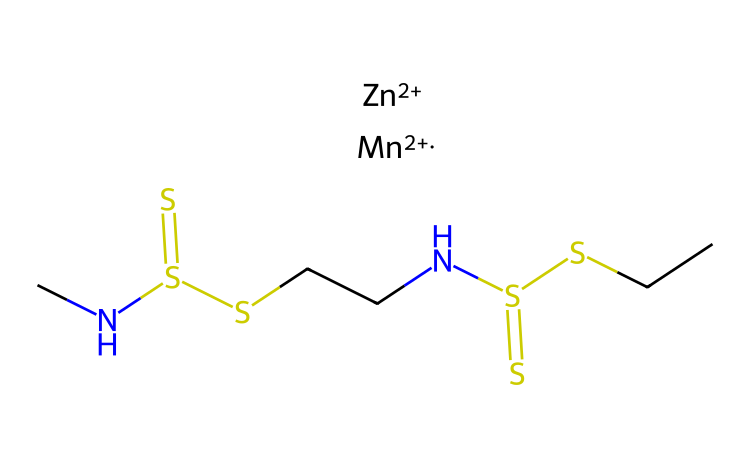What is the molecular formula of mancozeb? The SMILES representation provides information on the atoms present in the molecule. By interpreting the components, we find that mancozeb consists of carbon (C), hydrogen (H), nitrogen (N), sulfur (S), manganese (Mn), and zinc (Zn). The molecular formula can be derived as C4H6N2S4ZnMn.
Answer: C4H6N2S4ZnMn How many sulfur atoms are in this molecule? By carefully examining the SMILES notation, we can identify sulfur atoms represented by 'S'. In the structure, there are four 'S' present, indicating there are four sulfur atoms in the molecule.
Answer: 4 Which elements are represented by the symbols "Zn" and "Mn"? The chemical symbols "Zn" and "Mn" in the SMILES represent zinc and manganese, respectively. These symbols denote the presence of these two specific elements in the molecular structure of mancozeb.
Answer: zinc and manganese How many nitrogen atoms does mancozeb contain? The two nitrogen atoms (N) are seen in the SMILES representation. By counting the 'N' symbols present in the structure, we find there are two nitrogen atoms in the molecule.
Answer: 2 What is the role of mancozeb in agriculture? Mancozeb is primarily used as a fungicide in agriculture to protect crops from a broad spectrum of fungi. Its chemical structure enables it to inhibit fungal growth effectively, making it valuable for farmers.
Answer: fungicide Is mancozeb considered a heavy metal? Although mancozeb contains manganese and zinc, it is not classified as a heavy metal itself. It is a chemical compound used as a fungicide, but the presence of these metals makes its environmental impact a topic of discussion.
Answer: no 